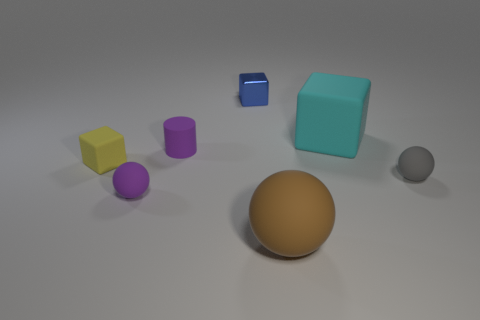Does the brown rubber ball have the same size as the gray rubber thing?
Your answer should be compact. No. There is a matte ball that is left of the cyan cube and behind the large brown rubber ball; what color is it?
Make the answer very short. Purple. The gray rubber ball is what size?
Provide a short and direct response. Small. Does the tiny sphere that is on the left side of the cyan thing have the same color as the small cylinder?
Give a very brief answer. Yes. Is the number of big rubber things behind the yellow thing greater than the number of gray rubber spheres left of the tiny rubber cylinder?
Provide a short and direct response. Yes. Is the number of big cyan objects greater than the number of small cyan cylinders?
Give a very brief answer. Yes. How big is the rubber thing that is both to the right of the small metal cube and on the left side of the cyan thing?
Provide a short and direct response. Large. What is the shape of the yellow rubber thing?
Your answer should be compact. Cube. Are there more rubber objects that are to the right of the tiny blue metal object than big metal things?
Your answer should be compact. Yes. There is a big thing in front of the thing on the right side of the rubber cube that is on the right side of the small blue object; what shape is it?
Provide a succinct answer. Sphere. 